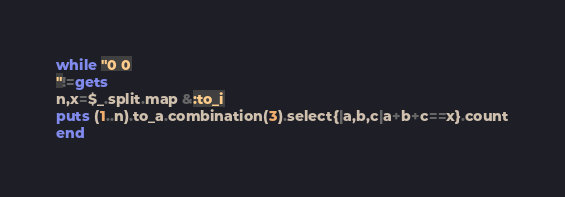<code> <loc_0><loc_0><loc_500><loc_500><_Ruby_>while "0 0
"!=gets
n,x=$_.split.map &:to_i
puts (1..n).to_a.combination(3).select{|a,b,c|a+b+c==x}.count
end
</code> 